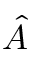Convert formula to latex. <formula><loc_0><loc_0><loc_500><loc_500>\hat { A }</formula> 